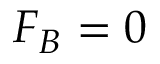Convert formula to latex. <formula><loc_0><loc_0><loc_500><loc_500>F _ { B } = 0</formula> 